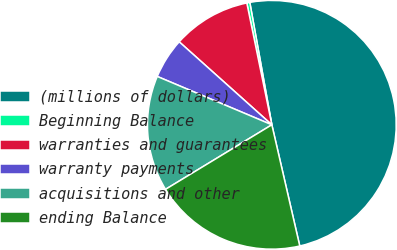Convert chart to OTSL. <chart><loc_0><loc_0><loc_500><loc_500><pie_chart><fcel>(millions of dollars)<fcel>Beginning Balance<fcel>warranties and guarantees<fcel>warranty payments<fcel>acquisitions and other<fcel>ending Balance<nl><fcel>49.23%<fcel>0.39%<fcel>10.15%<fcel>5.27%<fcel>15.04%<fcel>19.92%<nl></chart> 